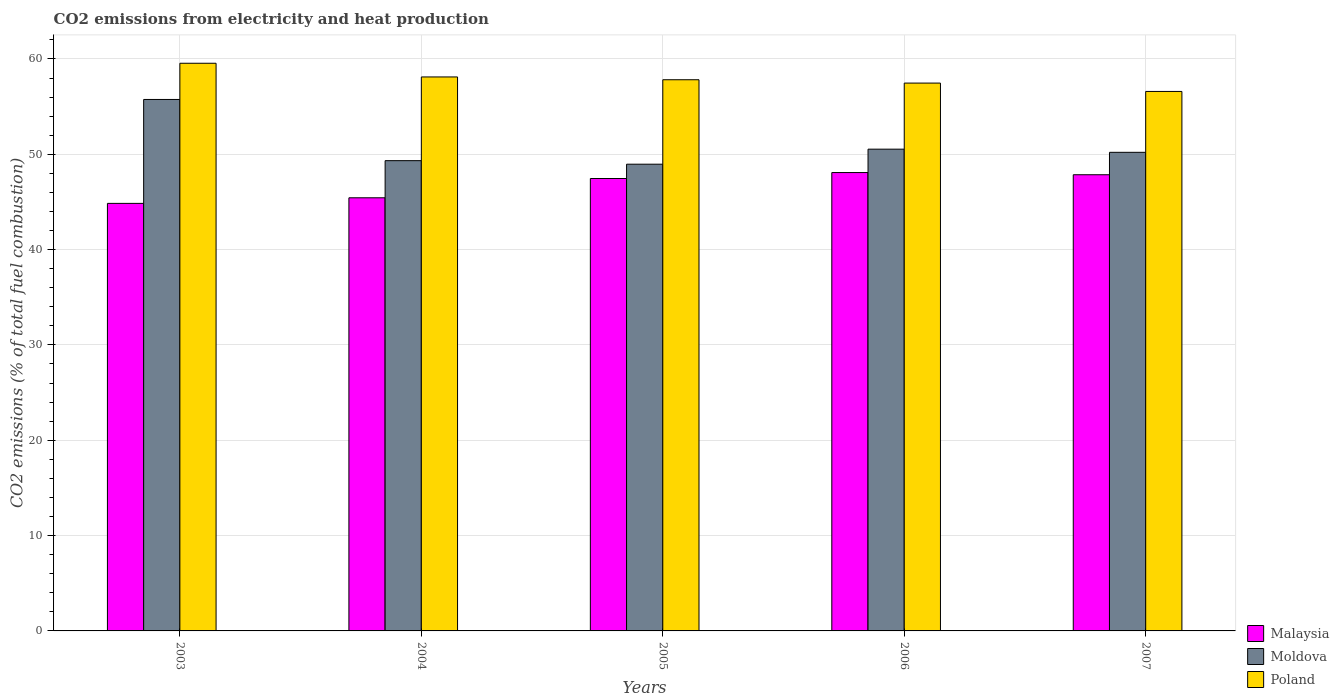How many different coloured bars are there?
Your response must be concise. 3. How many groups of bars are there?
Provide a short and direct response. 5. Are the number of bars per tick equal to the number of legend labels?
Your response must be concise. Yes. Are the number of bars on each tick of the X-axis equal?
Offer a very short reply. Yes. How many bars are there on the 4th tick from the right?
Your answer should be compact. 3. What is the amount of CO2 emitted in Malaysia in 2006?
Make the answer very short. 48.08. Across all years, what is the maximum amount of CO2 emitted in Poland?
Make the answer very short. 59.55. Across all years, what is the minimum amount of CO2 emitted in Malaysia?
Your answer should be compact. 44.85. In which year was the amount of CO2 emitted in Malaysia maximum?
Your answer should be compact. 2006. What is the total amount of CO2 emitted in Malaysia in the graph?
Give a very brief answer. 233.67. What is the difference between the amount of CO2 emitted in Malaysia in 2004 and that in 2006?
Offer a very short reply. -2.65. What is the difference between the amount of CO2 emitted in Poland in 2005 and the amount of CO2 emitted in Malaysia in 2003?
Your answer should be very brief. 12.97. What is the average amount of CO2 emitted in Moldova per year?
Give a very brief answer. 50.96. In the year 2005, what is the difference between the amount of CO2 emitted in Moldova and amount of CO2 emitted in Poland?
Your answer should be very brief. -8.86. In how many years, is the amount of CO2 emitted in Malaysia greater than 42 %?
Make the answer very short. 5. What is the ratio of the amount of CO2 emitted in Malaysia in 2003 to that in 2005?
Keep it short and to the point. 0.95. What is the difference between the highest and the second highest amount of CO2 emitted in Poland?
Keep it short and to the point. 1.44. What is the difference between the highest and the lowest amount of CO2 emitted in Poland?
Your response must be concise. 2.96. In how many years, is the amount of CO2 emitted in Moldova greater than the average amount of CO2 emitted in Moldova taken over all years?
Ensure brevity in your answer.  1. What does the 2nd bar from the right in 2006 represents?
Give a very brief answer. Moldova. How many bars are there?
Keep it short and to the point. 15. What is the difference between two consecutive major ticks on the Y-axis?
Provide a short and direct response. 10. Does the graph contain any zero values?
Keep it short and to the point. No. Where does the legend appear in the graph?
Offer a terse response. Bottom right. What is the title of the graph?
Offer a very short reply. CO2 emissions from electricity and heat production. What is the label or title of the X-axis?
Your answer should be compact. Years. What is the label or title of the Y-axis?
Offer a terse response. CO2 emissions (% of total fuel combustion). What is the CO2 emissions (% of total fuel combustion) of Malaysia in 2003?
Your answer should be compact. 44.85. What is the CO2 emissions (% of total fuel combustion) in Moldova in 2003?
Offer a terse response. 55.75. What is the CO2 emissions (% of total fuel combustion) in Poland in 2003?
Give a very brief answer. 59.55. What is the CO2 emissions (% of total fuel combustion) in Malaysia in 2004?
Your answer should be compact. 45.43. What is the CO2 emissions (% of total fuel combustion) of Moldova in 2004?
Offer a very short reply. 49.33. What is the CO2 emissions (% of total fuel combustion) in Poland in 2004?
Offer a terse response. 58.11. What is the CO2 emissions (% of total fuel combustion) of Malaysia in 2005?
Your answer should be very brief. 47.46. What is the CO2 emissions (% of total fuel combustion) in Moldova in 2005?
Ensure brevity in your answer.  48.96. What is the CO2 emissions (% of total fuel combustion) of Poland in 2005?
Provide a short and direct response. 57.82. What is the CO2 emissions (% of total fuel combustion) in Malaysia in 2006?
Provide a succinct answer. 48.08. What is the CO2 emissions (% of total fuel combustion) of Moldova in 2006?
Your answer should be very brief. 50.53. What is the CO2 emissions (% of total fuel combustion) in Poland in 2006?
Ensure brevity in your answer.  57.47. What is the CO2 emissions (% of total fuel combustion) of Malaysia in 2007?
Your answer should be very brief. 47.85. What is the CO2 emissions (% of total fuel combustion) in Moldova in 2007?
Your answer should be compact. 50.2. What is the CO2 emissions (% of total fuel combustion) of Poland in 2007?
Give a very brief answer. 56.59. Across all years, what is the maximum CO2 emissions (% of total fuel combustion) of Malaysia?
Provide a short and direct response. 48.08. Across all years, what is the maximum CO2 emissions (% of total fuel combustion) in Moldova?
Your answer should be compact. 55.75. Across all years, what is the maximum CO2 emissions (% of total fuel combustion) in Poland?
Offer a terse response. 59.55. Across all years, what is the minimum CO2 emissions (% of total fuel combustion) of Malaysia?
Your answer should be compact. 44.85. Across all years, what is the minimum CO2 emissions (% of total fuel combustion) of Moldova?
Keep it short and to the point. 48.96. Across all years, what is the minimum CO2 emissions (% of total fuel combustion) in Poland?
Make the answer very short. 56.59. What is the total CO2 emissions (% of total fuel combustion) in Malaysia in the graph?
Your answer should be very brief. 233.67. What is the total CO2 emissions (% of total fuel combustion) of Moldova in the graph?
Give a very brief answer. 254.78. What is the total CO2 emissions (% of total fuel combustion) in Poland in the graph?
Keep it short and to the point. 289.53. What is the difference between the CO2 emissions (% of total fuel combustion) of Malaysia in 2003 and that in 2004?
Make the answer very short. -0.59. What is the difference between the CO2 emissions (% of total fuel combustion) of Moldova in 2003 and that in 2004?
Keep it short and to the point. 6.42. What is the difference between the CO2 emissions (% of total fuel combustion) of Poland in 2003 and that in 2004?
Make the answer very short. 1.44. What is the difference between the CO2 emissions (% of total fuel combustion) of Malaysia in 2003 and that in 2005?
Your answer should be compact. -2.61. What is the difference between the CO2 emissions (% of total fuel combustion) of Moldova in 2003 and that in 2005?
Ensure brevity in your answer.  6.79. What is the difference between the CO2 emissions (% of total fuel combustion) of Poland in 2003 and that in 2005?
Keep it short and to the point. 1.73. What is the difference between the CO2 emissions (% of total fuel combustion) in Malaysia in 2003 and that in 2006?
Your answer should be very brief. -3.23. What is the difference between the CO2 emissions (% of total fuel combustion) in Moldova in 2003 and that in 2006?
Provide a succinct answer. 5.21. What is the difference between the CO2 emissions (% of total fuel combustion) in Poland in 2003 and that in 2006?
Offer a very short reply. 2.08. What is the difference between the CO2 emissions (% of total fuel combustion) in Malaysia in 2003 and that in 2007?
Ensure brevity in your answer.  -3. What is the difference between the CO2 emissions (% of total fuel combustion) in Moldova in 2003 and that in 2007?
Keep it short and to the point. 5.54. What is the difference between the CO2 emissions (% of total fuel combustion) in Poland in 2003 and that in 2007?
Provide a short and direct response. 2.96. What is the difference between the CO2 emissions (% of total fuel combustion) of Malaysia in 2004 and that in 2005?
Provide a short and direct response. -2.02. What is the difference between the CO2 emissions (% of total fuel combustion) in Moldova in 2004 and that in 2005?
Provide a short and direct response. 0.37. What is the difference between the CO2 emissions (% of total fuel combustion) of Poland in 2004 and that in 2005?
Make the answer very short. 0.29. What is the difference between the CO2 emissions (% of total fuel combustion) in Malaysia in 2004 and that in 2006?
Make the answer very short. -2.65. What is the difference between the CO2 emissions (% of total fuel combustion) of Moldova in 2004 and that in 2006?
Make the answer very short. -1.21. What is the difference between the CO2 emissions (% of total fuel combustion) of Poland in 2004 and that in 2006?
Keep it short and to the point. 0.64. What is the difference between the CO2 emissions (% of total fuel combustion) in Malaysia in 2004 and that in 2007?
Keep it short and to the point. -2.42. What is the difference between the CO2 emissions (% of total fuel combustion) in Moldova in 2004 and that in 2007?
Make the answer very short. -0.87. What is the difference between the CO2 emissions (% of total fuel combustion) in Poland in 2004 and that in 2007?
Ensure brevity in your answer.  1.52. What is the difference between the CO2 emissions (% of total fuel combustion) of Malaysia in 2005 and that in 2006?
Give a very brief answer. -0.62. What is the difference between the CO2 emissions (% of total fuel combustion) in Moldova in 2005 and that in 2006?
Make the answer very short. -1.58. What is the difference between the CO2 emissions (% of total fuel combustion) in Poland in 2005 and that in 2006?
Your answer should be very brief. 0.35. What is the difference between the CO2 emissions (% of total fuel combustion) of Malaysia in 2005 and that in 2007?
Offer a terse response. -0.4. What is the difference between the CO2 emissions (% of total fuel combustion) of Moldova in 2005 and that in 2007?
Provide a short and direct response. -1.25. What is the difference between the CO2 emissions (% of total fuel combustion) of Poland in 2005 and that in 2007?
Provide a short and direct response. 1.23. What is the difference between the CO2 emissions (% of total fuel combustion) in Malaysia in 2006 and that in 2007?
Offer a very short reply. 0.23. What is the difference between the CO2 emissions (% of total fuel combustion) of Moldova in 2006 and that in 2007?
Ensure brevity in your answer.  0.33. What is the difference between the CO2 emissions (% of total fuel combustion) in Poland in 2006 and that in 2007?
Offer a very short reply. 0.88. What is the difference between the CO2 emissions (% of total fuel combustion) of Malaysia in 2003 and the CO2 emissions (% of total fuel combustion) of Moldova in 2004?
Provide a short and direct response. -4.48. What is the difference between the CO2 emissions (% of total fuel combustion) of Malaysia in 2003 and the CO2 emissions (% of total fuel combustion) of Poland in 2004?
Provide a short and direct response. -13.26. What is the difference between the CO2 emissions (% of total fuel combustion) of Moldova in 2003 and the CO2 emissions (% of total fuel combustion) of Poland in 2004?
Your response must be concise. -2.36. What is the difference between the CO2 emissions (% of total fuel combustion) in Malaysia in 2003 and the CO2 emissions (% of total fuel combustion) in Moldova in 2005?
Provide a succinct answer. -4.11. What is the difference between the CO2 emissions (% of total fuel combustion) of Malaysia in 2003 and the CO2 emissions (% of total fuel combustion) of Poland in 2005?
Offer a very short reply. -12.97. What is the difference between the CO2 emissions (% of total fuel combustion) in Moldova in 2003 and the CO2 emissions (% of total fuel combustion) in Poland in 2005?
Your response must be concise. -2.07. What is the difference between the CO2 emissions (% of total fuel combustion) of Malaysia in 2003 and the CO2 emissions (% of total fuel combustion) of Moldova in 2006?
Ensure brevity in your answer.  -5.69. What is the difference between the CO2 emissions (% of total fuel combustion) of Malaysia in 2003 and the CO2 emissions (% of total fuel combustion) of Poland in 2006?
Offer a very short reply. -12.62. What is the difference between the CO2 emissions (% of total fuel combustion) of Moldova in 2003 and the CO2 emissions (% of total fuel combustion) of Poland in 2006?
Your answer should be compact. -1.72. What is the difference between the CO2 emissions (% of total fuel combustion) in Malaysia in 2003 and the CO2 emissions (% of total fuel combustion) in Moldova in 2007?
Provide a short and direct response. -5.36. What is the difference between the CO2 emissions (% of total fuel combustion) in Malaysia in 2003 and the CO2 emissions (% of total fuel combustion) in Poland in 2007?
Provide a short and direct response. -11.74. What is the difference between the CO2 emissions (% of total fuel combustion) of Moldova in 2003 and the CO2 emissions (% of total fuel combustion) of Poland in 2007?
Offer a very short reply. -0.84. What is the difference between the CO2 emissions (% of total fuel combustion) of Malaysia in 2004 and the CO2 emissions (% of total fuel combustion) of Moldova in 2005?
Make the answer very short. -3.52. What is the difference between the CO2 emissions (% of total fuel combustion) of Malaysia in 2004 and the CO2 emissions (% of total fuel combustion) of Poland in 2005?
Give a very brief answer. -12.38. What is the difference between the CO2 emissions (% of total fuel combustion) of Moldova in 2004 and the CO2 emissions (% of total fuel combustion) of Poland in 2005?
Offer a very short reply. -8.49. What is the difference between the CO2 emissions (% of total fuel combustion) in Malaysia in 2004 and the CO2 emissions (% of total fuel combustion) in Moldova in 2006?
Ensure brevity in your answer.  -5.1. What is the difference between the CO2 emissions (% of total fuel combustion) of Malaysia in 2004 and the CO2 emissions (% of total fuel combustion) of Poland in 2006?
Provide a short and direct response. -12.03. What is the difference between the CO2 emissions (% of total fuel combustion) in Moldova in 2004 and the CO2 emissions (% of total fuel combustion) in Poland in 2006?
Give a very brief answer. -8.14. What is the difference between the CO2 emissions (% of total fuel combustion) of Malaysia in 2004 and the CO2 emissions (% of total fuel combustion) of Moldova in 2007?
Keep it short and to the point. -4.77. What is the difference between the CO2 emissions (% of total fuel combustion) in Malaysia in 2004 and the CO2 emissions (% of total fuel combustion) in Poland in 2007?
Make the answer very short. -11.15. What is the difference between the CO2 emissions (% of total fuel combustion) of Moldova in 2004 and the CO2 emissions (% of total fuel combustion) of Poland in 2007?
Provide a succinct answer. -7.26. What is the difference between the CO2 emissions (% of total fuel combustion) of Malaysia in 2005 and the CO2 emissions (% of total fuel combustion) of Moldova in 2006?
Give a very brief answer. -3.08. What is the difference between the CO2 emissions (% of total fuel combustion) of Malaysia in 2005 and the CO2 emissions (% of total fuel combustion) of Poland in 2006?
Provide a succinct answer. -10.01. What is the difference between the CO2 emissions (% of total fuel combustion) in Moldova in 2005 and the CO2 emissions (% of total fuel combustion) in Poland in 2006?
Your answer should be compact. -8.51. What is the difference between the CO2 emissions (% of total fuel combustion) of Malaysia in 2005 and the CO2 emissions (% of total fuel combustion) of Moldova in 2007?
Your answer should be compact. -2.75. What is the difference between the CO2 emissions (% of total fuel combustion) in Malaysia in 2005 and the CO2 emissions (% of total fuel combustion) in Poland in 2007?
Ensure brevity in your answer.  -9.13. What is the difference between the CO2 emissions (% of total fuel combustion) of Moldova in 2005 and the CO2 emissions (% of total fuel combustion) of Poland in 2007?
Your response must be concise. -7.63. What is the difference between the CO2 emissions (% of total fuel combustion) in Malaysia in 2006 and the CO2 emissions (% of total fuel combustion) in Moldova in 2007?
Keep it short and to the point. -2.12. What is the difference between the CO2 emissions (% of total fuel combustion) in Malaysia in 2006 and the CO2 emissions (% of total fuel combustion) in Poland in 2007?
Provide a succinct answer. -8.51. What is the difference between the CO2 emissions (% of total fuel combustion) in Moldova in 2006 and the CO2 emissions (% of total fuel combustion) in Poland in 2007?
Your response must be concise. -6.05. What is the average CO2 emissions (% of total fuel combustion) of Malaysia per year?
Your response must be concise. 46.73. What is the average CO2 emissions (% of total fuel combustion) of Moldova per year?
Provide a succinct answer. 50.96. What is the average CO2 emissions (% of total fuel combustion) of Poland per year?
Make the answer very short. 57.91. In the year 2003, what is the difference between the CO2 emissions (% of total fuel combustion) of Malaysia and CO2 emissions (% of total fuel combustion) of Moldova?
Keep it short and to the point. -10.9. In the year 2003, what is the difference between the CO2 emissions (% of total fuel combustion) of Malaysia and CO2 emissions (% of total fuel combustion) of Poland?
Keep it short and to the point. -14.7. In the year 2003, what is the difference between the CO2 emissions (% of total fuel combustion) in Moldova and CO2 emissions (% of total fuel combustion) in Poland?
Your answer should be compact. -3.8. In the year 2004, what is the difference between the CO2 emissions (% of total fuel combustion) in Malaysia and CO2 emissions (% of total fuel combustion) in Moldova?
Offer a very short reply. -3.9. In the year 2004, what is the difference between the CO2 emissions (% of total fuel combustion) of Malaysia and CO2 emissions (% of total fuel combustion) of Poland?
Provide a succinct answer. -12.68. In the year 2004, what is the difference between the CO2 emissions (% of total fuel combustion) in Moldova and CO2 emissions (% of total fuel combustion) in Poland?
Offer a terse response. -8.78. In the year 2005, what is the difference between the CO2 emissions (% of total fuel combustion) of Malaysia and CO2 emissions (% of total fuel combustion) of Moldova?
Make the answer very short. -1.5. In the year 2005, what is the difference between the CO2 emissions (% of total fuel combustion) of Malaysia and CO2 emissions (% of total fuel combustion) of Poland?
Keep it short and to the point. -10.36. In the year 2005, what is the difference between the CO2 emissions (% of total fuel combustion) of Moldova and CO2 emissions (% of total fuel combustion) of Poland?
Provide a short and direct response. -8.86. In the year 2006, what is the difference between the CO2 emissions (% of total fuel combustion) of Malaysia and CO2 emissions (% of total fuel combustion) of Moldova?
Your answer should be compact. -2.45. In the year 2006, what is the difference between the CO2 emissions (% of total fuel combustion) in Malaysia and CO2 emissions (% of total fuel combustion) in Poland?
Make the answer very short. -9.38. In the year 2006, what is the difference between the CO2 emissions (% of total fuel combustion) of Moldova and CO2 emissions (% of total fuel combustion) of Poland?
Keep it short and to the point. -6.93. In the year 2007, what is the difference between the CO2 emissions (% of total fuel combustion) in Malaysia and CO2 emissions (% of total fuel combustion) in Moldova?
Your answer should be compact. -2.35. In the year 2007, what is the difference between the CO2 emissions (% of total fuel combustion) of Malaysia and CO2 emissions (% of total fuel combustion) of Poland?
Keep it short and to the point. -8.74. In the year 2007, what is the difference between the CO2 emissions (% of total fuel combustion) of Moldova and CO2 emissions (% of total fuel combustion) of Poland?
Your answer should be very brief. -6.39. What is the ratio of the CO2 emissions (% of total fuel combustion) in Malaysia in 2003 to that in 2004?
Keep it short and to the point. 0.99. What is the ratio of the CO2 emissions (% of total fuel combustion) of Moldova in 2003 to that in 2004?
Your answer should be very brief. 1.13. What is the ratio of the CO2 emissions (% of total fuel combustion) of Poland in 2003 to that in 2004?
Keep it short and to the point. 1.02. What is the ratio of the CO2 emissions (% of total fuel combustion) in Malaysia in 2003 to that in 2005?
Provide a succinct answer. 0.94. What is the ratio of the CO2 emissions (% of total fuel combustion) in Moldova in 2003 to that in 2005?
Give a very brief answer. 1.14. What is the ratio of the CO2 emissions (% of total fuel combustion) of Poland in 2003 to that in 2005?
Make the answer very short. 1.03. What is the ratio of the CO2 emissions (% of total fuel combustion) of Malaysia in 2003 to that in 2006?
Provide a succinct answer. 0.93. What is the ratio of the CO2 emissions (% of total fuel combustion) of Moldova in 2003 to that in 2006?
Ensure brevity in your answer.  1.1. What is the ratio of the CO2 emissions (% of total fuel combustion) in Poland in 2003 to that in 2006?
Offer a very short reply. 1.04. What is the ratio of the CO2 emissions (% of total fuel combustion) of Malaysia in 2003 to that in 2007?
Offer a terse response. 0.94. What is the ratio of the CO2 emissions (% of total fuel combustion) in Moldova in 2003 to that in 2007?
Provide a succinct answer. 1.11. What is the ratio of the CO2 emissions (% of total fuel combustion) of Poland in 2003 to that in 2007?
Your response must be concise. 1.05. What is the ratio of the CO2 emissions (% of total fuel combustion) in Malaysia in 2004 to that in 2005?
Provide a succinct answer. 0.96. What is the ratio of the CO2 emissions (% of total fuel combustion) of Moldova in 2004 to that in 2005?
Your answer should be very brief. 1.01. What is the ratio of the CO2 emissions (% of total fuel combustion) of Poland in 2004 to that in 2005?
Offer a very short reply. 1.01. What is the ratio of the CO2 emissions (% of total fuel combustion) of Malaysia in 2004 to that in 2006?
Your answer should be compact. 0.94. What is the ratio of the CO2 emissions (% of total fuel combustion) in Moldova in 2004 to that in 2006?
Ensure brevity in your answer.  0.98. What is the ratio of the CO2 emissions (% of total fuel combustion) in Poland in 2004 to that in 2006?
Offer a very short reply. 1.01. What is the ratio of the CO2 emissions (% of total fuel combustion) of Malaysia in 2004 to that in 2007?
Provide a short and direct response. 0.95. What is the ratio of the CO2 emissions (% of total fuel combustion) in Moldova in 2004 to that in 2007?
Your response must be concise. 0.98. What is the ratio of the CO2 emissions (% of total fuel combustion) in Poland in 2004 to that in 2007?
Your answer should be very brief. 1.03. What is the ratio of the CO2 emissions (% of total fuel combustion) of Malaysia in 2005 to that in 2006?
Ensure brevity in your answer.  0.99. What is the ratio of the CO2 emissions (% of total fuel combustion) of Moldova in 2005 to that in 2006?
Make the answer very short. 0.97. What is the ratio of the CO2 emissions (% of total fuel combustion) in Moldova in 2005 to that in 2007?
Give a very brief answer. 0.98. What is the ratio of the CO2 emissions (% of total fuel combustion) in Poland in 2005 to that in 2007?
Provide a short and direct response. 1.02. What is the ratio of the CO2 emissions (% of total fuel combustion) in Malaysia in 2006 to that in 2007?
Offer a very short reply. 1. What is the ratio of the CO2 emissions (% of total fuel combustion) in Moldova in 2006 to that in 2007?
Give a very brief answer. 1.01. What is the ratio of the CO2 emissions (% of total fuel combustion) of Poland in 2006 to that in 2007?
Provide a short and direct response. 1.02. What is the difference between the highest and the second highest CO2 emissions (% of total fuel combustion) in Malaysia?
Make the answer very short. 0.23. What is the difference between the highest and the second highest CO2 emissions (% of total fuel combustion) in Moldova?
Provide a short and direct response. 5.21. What is the difference between the highest and the second highest CO2 emissions (% of total fuel combustion) in Poland?
Your answer should be very brief. 1.44. What is the difference between the highest and the lowest CO2 emissions (% of total fuel combustion) in Malaysia?
Make the answer very short. 3.23. What is the difference between the highest and the lowest CO2 emissions (% of total fuel combustion) in Moldova?
Your response must be concise. 6.79. What is the difference between the highest and the lowest CO2 emissions (% of total fuel combustion) of Poland?
Your response must be concise. 2.96. 